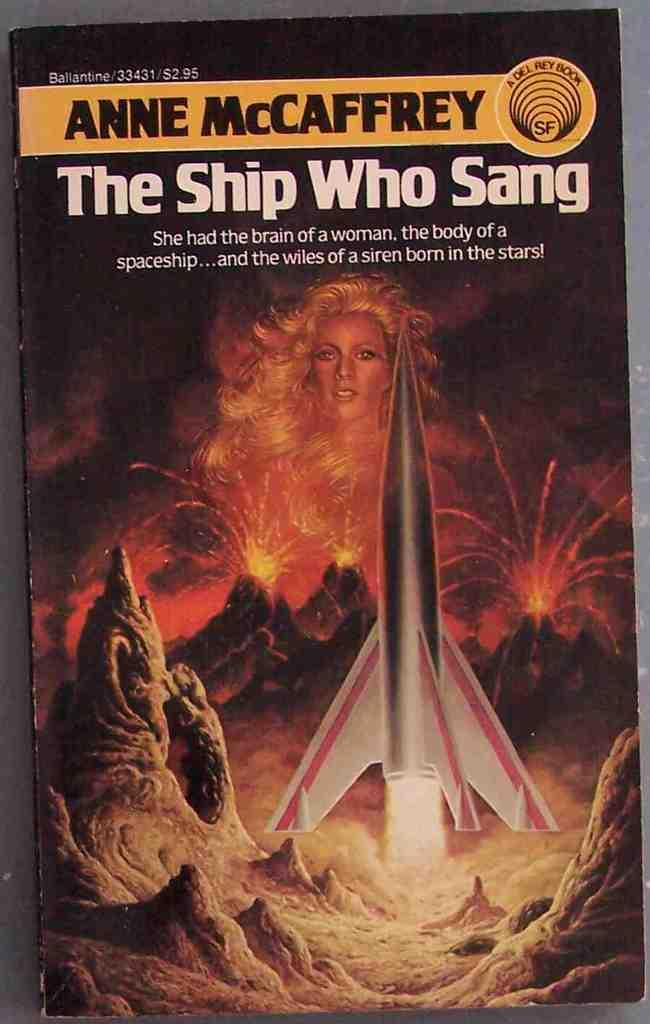What type of publication does the image represent? The image is the front cover of a book. Who or what is depicted on the book cover? There is a woman and a rocket depicted on the cover. What other objects are present on the book cover? There are stones depicted on the cover. Can you tell if the image was taken during the day or night? The image was likely taken during the day. What type of market offer is being made by the woman on the book cover? There is no market offer being made by the woman on the book cover, as the image does not depict a market or any offer being made. 